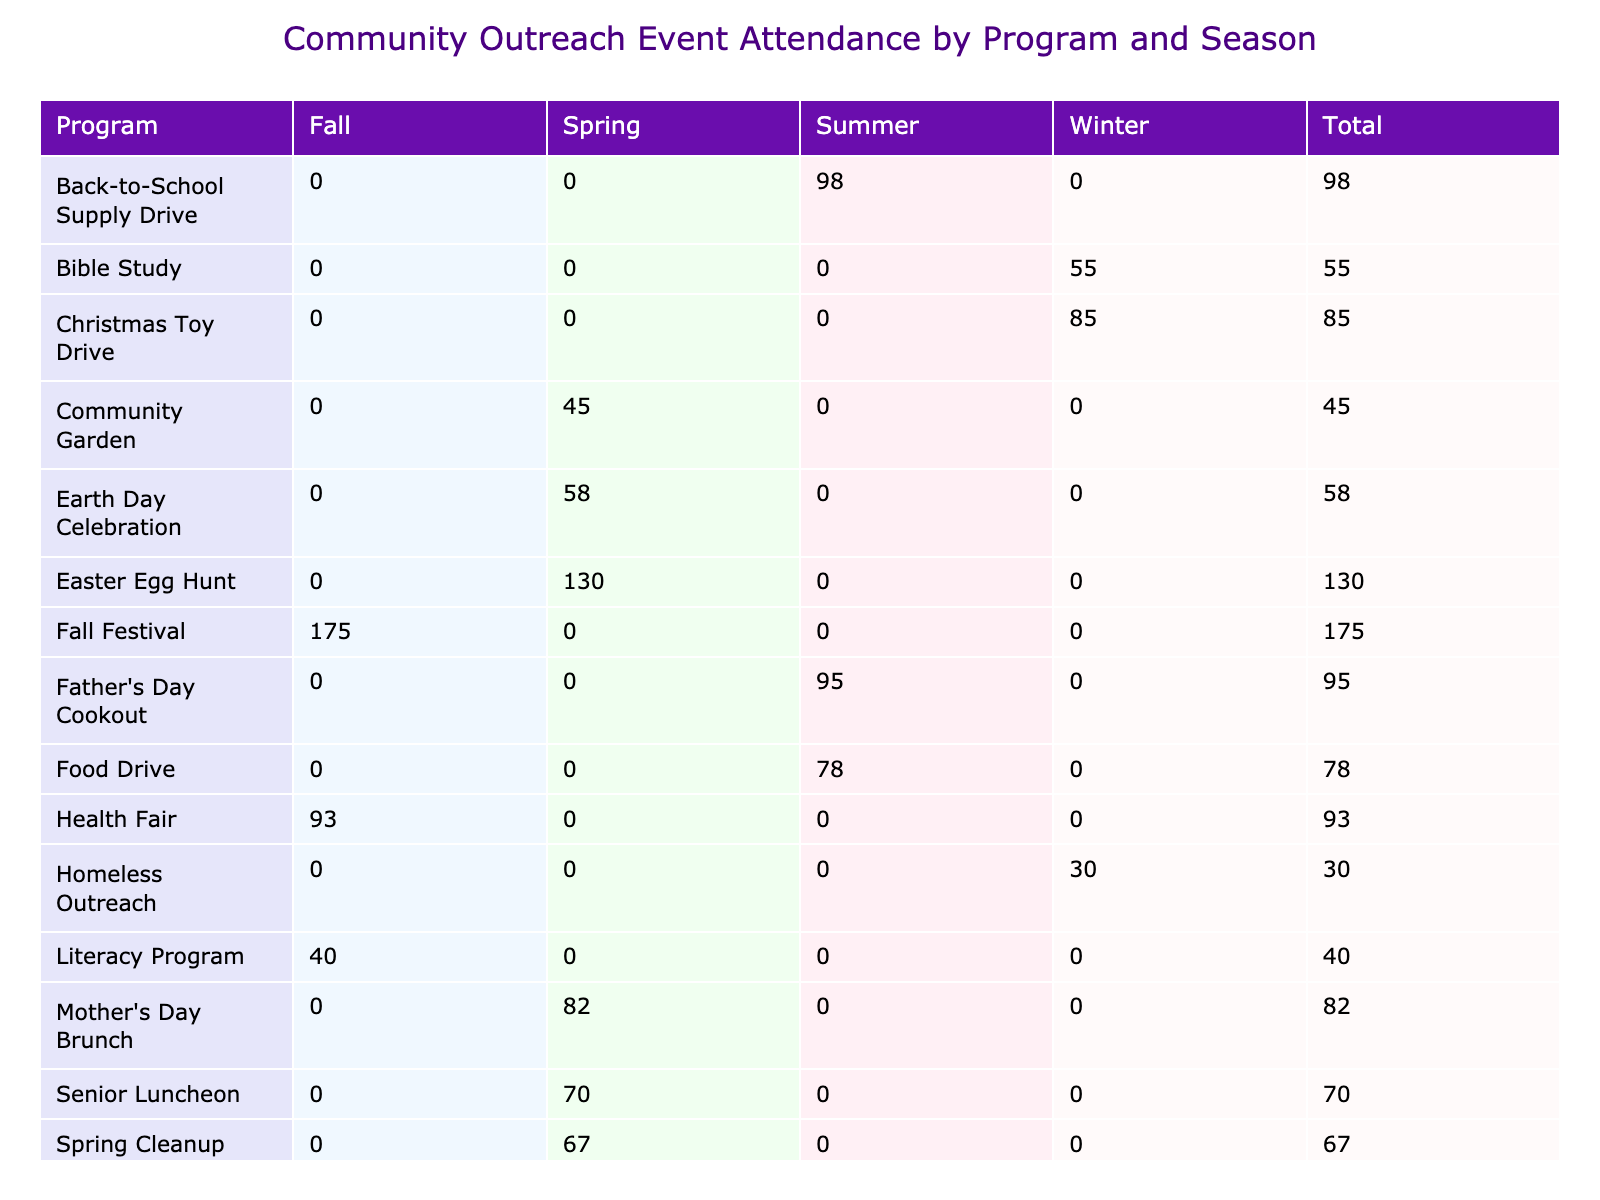What is the total attendance for the Thanksgiving Meal program? The attendance for the Thanksgiving Meal in the Fall season is listed in the table as 150. Since this is the only entry for that program, the total attendance is simply 150.
Answer: 150 Which program had the highest attendance in the Spring season? In the Spring season, the programs and their attendances are Easter Egg Hunt (130), Senior Luncheon (70), Community Garden (45), Spring Cleanup (67), and Mother's Day Brunch (82). The highest attendance is for the Easter Egg Hunt, which had 130 attendees.
Answer: Easter Egg Hunt Is there any program that had an attendance of more than 100 in the Winter season? In the Winter season, the programs listed are Christmas Toy Drive (85), Winter Coat Distribution (112), Bible Study (55), Youth Choir Performance (88), and Homeless Outreach (30). The Winter Coat Distribution has an attendance of 112, which is more than 100.
Answer: Yes What is the total attendance across all programs for the Summer season? The attendance for the Summer season programs is as follows: Food Drive (78), Vacation Bible School (105), Youth Sports Camp (62), Back-to-School Supply Drive (98), and Father's Day Cookout (95). Summing these values gives us: 78 + 105 + 62 + 98 + 95 = 438.
Answer: 438 Are there any programs specifically for Seniors listed? The only program in the table that specifically targets Seniors is the Senior Luncheon in the Spring season, which had an attendance of 70.
Answer: Yes Which season had the highest overall attendance across all programs? To determine the total attendance for each season: Summer (438), Fall (308), Winter (255), Spring (367). The highest attendance is in the Summer season with a total of 438 attendees.
Answer: Summer How many programs had an attendance of less than 50? By examining the table, we can see that there are no programs with an attendance of less than 50. The lowest attendance recorded is 30 for the Homeless Outreach in Winter. Therefore, the count is 0.
Answer: 0 What is the average attendance for the Fall season programs? The attendance for the Fall season programs includes: Health Fair (93), Thanksgiving Meal (150), Fall Festival (175), and Literacy Program (40). To find the average, we first sum these values: 93 + 150 + 175 + 40 = 458. Since there are 4 programs, the average is 458 / 4 = 114.5.
Answer: 114.5 Which day of the week had the most events scheduled? By analyzing the data for each day of the week: Saturday (5 events), Sunday (4 events), Monday (1 event), Tuesday (2 events), Wednesday (2 events), and Thursday (1 event). The most events were held on Saturday with 5 events.
Answer: Saturday 